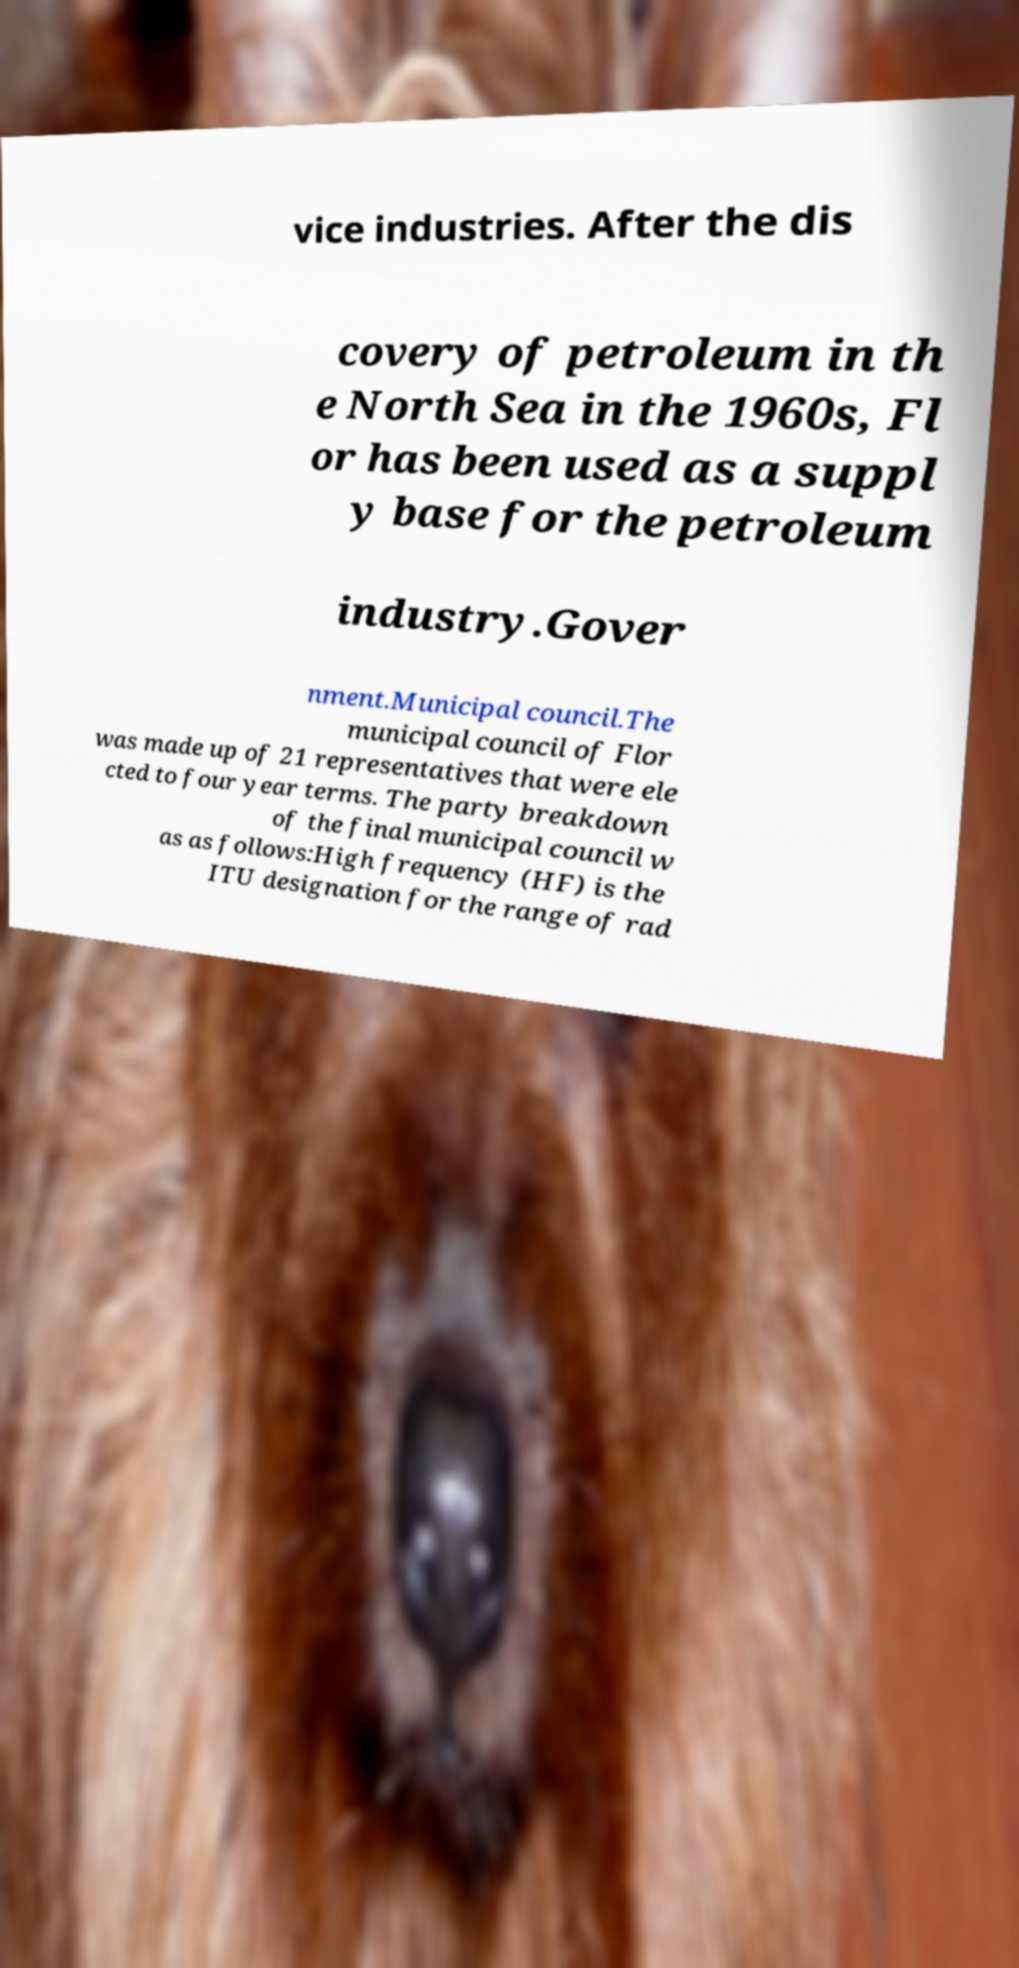I need the written content from this picture converted into text. Can you do that? vice industries. After the dis covery of petroleum in th e North Sea in the 1960s, Fl or has been used as a suppl y base for the petroleum industry.Gover nment.Municipal council.The municipal council of Flor was made up of 21 representatives that were ele cted to four year terms. The party breakdown of the final municipal council w as as follows:High frequency (HF) is the ITU designation for the range of rad 